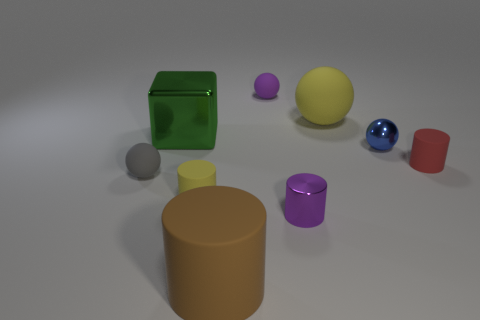What number of other objects are the same shape as the tiny yellow rubber object?
Offer a very short reply. 3. There is a yellow object in front of the ball that is left of the big green object; how many balls are to the left of it?
Offer a very short reply. 1. The matte cylinder in front of the tiny yellow object is what color?
Provide a short and direct response. Brown. Is the color of the tiny thing behind the green object the same as the metallic cylinder?
Offer a terse response. Yes. The other metal thing that is the same shape as the small gray object is what size?
Ensure brevity in your answer.  Small. What material is the tiny cylinder that is right of the yellow rubber object on the right side of the small sphere that is behind the metallic cube?
Give a very brief answer. Rubber. Are there more shiny things to the left of the big yellow rubber object than metallic cylinders that are right of the small purple shiny object?
Keep it short and to the point. Yes. Do the blue thing and the shiny block have the same size?
Make the answer very short. No. What is the color of the other small metallic object that is the same shape as the gray thing?
Give a very brief answer. Blue. What number of small cylinders are the same color as the large sphere?
Make the answer very short. 1. 